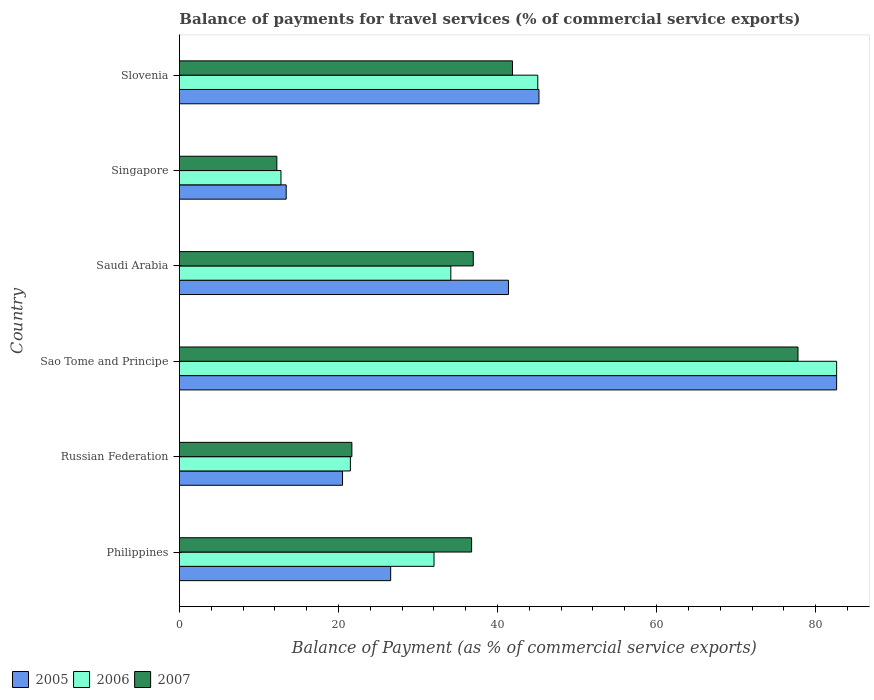How many groups of bars are there?
Make the answer very short. 6. What is the label of the 2nd group of bars from the top?
Offer a very short reply. Singapore. In how many cases, is the number of bars for a given country not equal to the number of legend labels?
Keep it short and to the point. 0. What is the balance of payments for travel services in 2007 in Singapore?
Offer a very short reply. 12.25. Across all countries, what is the maximum balance of payments for travel services in 2007?
Offer a terse response. 77.78. Across all countries, what is the minimum balance of payments for travel services in 2007?
Provide a short and direct response. 12.25. In which country was the balance of payments for travel services in 2007 maximum?
Provide a short and direct response. Sao Tome and Principe. In which country was the balance of payments for travel services in 2007 minimum?
Offer a very short reply. Singapore. What is the total balance of payments for travel services in 2005 in the graph?
Give a very brief answer. 229.74. What is the difference between the balance of payments for travel services in 2007 in Russian Federation and that in Saudi Arabia?
Provide a succinct answer. -15.27. What is the difference between the balance of payments for travel services in 2005 in Philippines and the balance of payments for travel services in 2007 in Singapore?
Provide a short and direct response. 14.31. What is the average balance of payments for travel services in 2007 per country?
Keep it short and to the point. 37.88. What is the difference between the balance of payments for travel services in 2006 and balance of payments for travel services in 2005 in Russian Federation?
Make the answer very short. 0.99. What is the ratio of the balance of payments for travel services in 2006 in Philippines to that in Russian Federation?
Your answer should be compact. 1.49. What is the difference between the highest and the second highest balance of payments for travel services in 2005?
Provide a succinct answer. 37.43. What is the difference between the highest and the lowest balance of payments for travel services in 2005?
Make the answer very short. 69.22. Is the sum of the balance of payments for travel services in 2005 in Sao Tome and Principe and Slovenia greater than the maximum balance of payments for travel services in 2006 across all countries?
Your answer should be very brief. Yes. What does the 3rd bar from the top in Philippines represents?
Provide a short and direct response. 2005. What does the 1st bar from the bottom in Saudi Arabia represents?
Ensure brevity in your answer.  2005. How many bars are there?
Keep it short and to the point. 18. How many countries are there in the graph?
Make the answer very short. 6. What is the difference between two consecutive major ticks on the X-axis?
Your response must be concise. 20. Does the graph contain grids?
Make the answer very short. No. What is the title of the graph?
Make the answer very short. Balance of payments for travel services (% of commercial service exports). Does "1999" appear as one of the legend labels in the graph?
Offer a terse response. No. What is the label or title of the X-axis?
Your answer should be compact. Balance of Payment (as % of commercial service exports). What is the Balance of Payment (as % of commercial service exports) in 2005 in Philippines?
Your response must be concise. 26.56. What is the Balance of Payment (as % of commercial service exports) in 2006 in Philippines?
Make the answer very short. 32.02. What is the Balance of Payment (as % of commercial service exports) of 2007 in Philippines?
Provide a short and direct response. 36.74. What is the Balance of Payment (as % of commercial service exports) of 2005 in Russian Federation?
Provide a short and direct response. 20.51. What is the Balance of Payment (as % of commercial service exports) of 2006 in Russian Federation?
Your response must be concise. 21.5. What is the Balance of Payment (as % of commercial service exports) of 2007 in Russian Federation?
Ensure brevity in your answer.  21.69. What is the Balance of Payment (as % of commercial service exports) of 2005 in Sao Tome and Principe?
Provide a succinct answer. 82.64. What is the Balance of Payment (as % of commercial service exports) of 2006 in Sao Tome and Principe?
Provide a succinct answer. 82.64. What is the Balance of Payment (as % of commercial service exports) in 2007 in Sao Tome and Principe?
Provide a short and direct response. 77.78. What is the Balance of Payment (as % of commercial service exports) in 2005 in Saudi Arabia?
Ensure brevity in your answer.  41.38. What is the Balance of Payment (as % of commercial service exports) in 2006 in Saudi Arabia?
Ensure brevity in your answer.  34.13. What is the Balance of Payment (as % of commercial service exports) of 2007 in Saudi Arabia?
Provide a succinct answer. 36.95. What is the Balance of Payment (as % of commercial service exports) in 2005 in Singapore?
Ensure brevity in your answer.  13.43. What is the Balance of Payment (as % of commercial service exports) of 2006 in Singapore?
Your answer should be compact. 12.77. What is the Balance of Payment (as % of commercial service exports) in 2007 in Singapore?
Make the answer very short. 12.25. What is the Balance of Payment (as % of commercial service exports) of 2005 in Slovenia?
Your answer should be very brief. 45.21. What is the Balance of Payment (as % of commercial service exports) in 2006 in Slovenia?
Your response must be concise. 45.06. What is the Balance of Payment (as % of commercial service exports) of 2007 in Slovenia?
Provide a succinct answer. 41.88. Across all countries, what is the maximum Balance of Payment (as % of commercial service exports) in 2005?
Offer a very short reply. 82.64. Across all countries, what is the maximum Balance of Payment (as % of commercial service exports) in 2006?
Give a very brief answer. 82.64. Across all countries, what is the maximum Balance of Payment (as % of commercial service exports) in 2007?
Your answer should be very brief. 77.78. Across all countries, what is the minimum Balance of Payment (as % of commercial service exports) in 2005?
Provide a succinct answer. 13.43. Across all countries, what is the minimum Balance of Payment (as % of commercial service exports) of 2006?
Your answer should be compact. 12.77. Across all countries, what is the minimum Balance of Payment (as % of commercial service exports) in 2007?
Provide a succinct answer. 12.25. What is the total Balance of Payment (as % of commercial service exports) of 2005 in the graph?
Ensure brevity in your answer.  229.74. What is the total Balance of Payment (as % of commercial service exports) of 2006 in the graph?
Ensure brevity in your answer.  228.12. What is the total Balance of Payment (as % of commercial service exports) of 2007 in the graph?
Ensure brevity in your answer.  227.3. What is the difference between the Balance of Payment (as % of commercial service exports) in 2005 in Philippines and that in Russian Federation?
Keep it short and to the point. 6.05. What is the difference between the Balance of Payment (as % of commercial service exports) in 2006 in Philippines and that in Russian Federation?
Your response must be concise. 10.52. What is the difference between the Balance of Payment (as % of commercial service exports) in 2007 in Philippines and that in Russian Federation?
Offer a terse response. 15.06. What is the difference between the Balance of Payment (as % of commercial service exports) in 2005 in Philippines and that in Sao Tome and Principe?
Give a very brief answer. -56.08. What is the difference between the Balance of Payment (as % of commercial service exports) of 2006 in Philippines and that in Sao Tome and Principe?
Your answer should be very brief. -50.63. What is the difference between the Balance of Payment (as % of commercial service exports) in 2007 in Philippines and that in Sao Tome and Principe?
Provide a short and direct response. -41.04. What is the difference between the Balance of Payment (as % of commercial service exports) of 2005 in Philippines and that in Saudi Arabia?
Your response must be concise. -14.81. What is the difference between the Balance of Payment (as % of commercial service exports) in 2006 in Philippines and that in Saudi Arabia?
Your answer should be compact. -2.11. What is the difference between the Balance of Payment (as % of commercial service exports) of 2007 in Philippines and that in Saudi Arabia?
Your response must be concise. -0.21. What is the difference between the Balance of Payment (as % of commercial service exports) of 2005 in Philippines and that in Singapore?
Provide a short and direct response. 13.14. What is the difference between the Balance of Payment (as % of commercial service exports) in 2006 in Philippines and that in Singapore?
Provide a succinct answer. 19.25. What is the difference between the Balance of Payment (as % of commercial service exports) in 2007 in Philippines and that in Singapore?
Offer a very short reply. 24.49. What is the difference between the Balance of Payment (as % of commercial service exports) of 2005 in Philippines and that in Slovenia?
Offer a terse response. -18.65. What is the difference between the Balance of Payment (as % of commercial service exports) of 2006 in Philippines and that in Slovenia?
Provide a succinct answer. -13.05. What is the difference between the Balance of Payment (as % of commercial service exports) of 2007 in Philippines and that in Slovenia?
Give a very brief answer. -5.14. What is the difference between the Balance of Payment (as % of commercial service exports) in 2005 in Russian Federation and that in Sao Tome and Principe?
Provide a short and direct response. -62.13. What is the difference between the Balance of Payment (as % of commercial service exports) in 2006 in Russian Federation and that in Sao Tome and Principe?
Your answer should be compact. -61.15. What is the difference between the Balance of Payment (as % of commercial service exports) of 2007 in Russian Federation and that in Sao Tome and Principe?
Make the answer very short. -56.1. What is the difference between the Balance of Payment (as % of commercial service exports) in 2005 in Russian Federation and that in Saudi Arabia?
Provide a succinct answer. -20.87. What is the difference between the Balance of Payment (as % of commercial service exports) of 2006 in Russian Federation and that in Saudi Arabia?
Keep it short and to the point. -12.63. What is the difference between the Balance of Payment (as % of commercial service exports) of 2007 in Russian Federation and that in Saudi Arabia?
Give a very brief answer. -15.27. What is the difference between the Balance of Payment (as % of commercial service exports) in 2005 in Russian Federation and that in Singapore?
Your answer should be very brief. 7.08. What is the difference between the Balance of Payment (as % of commercial service exports) of 2006 in Russian Federation and that in Singapore?
Keep it short and to the point. 8.73. What is the difference between the Balance of Payment (as % of commercial service exports) in 2007 in Russian Federation and that in Singapore?
Your answer should be very brief. 9.43. What is the difference between the Balance of Payment (as % of commercial service exports) in 2005 in Russian Federation and that in Slovenia?
Give a very brief answer. -24.7. What is the difference between the Balance of Payment (as % of commercial service exports) of 2006 in Russian Federation and that in Slovenia?
Your answer should be very brief. -23.57. What is the difference between the Balance of Payment (as % of commercial service exports) of 2007 in Russian Federation and that in Slovenia?
Make the answer very short. -20.2. What is the difference between the Balance of Payment (as % of commercial service exports) in 2005 in Sao Tome and Principe and that in Saudi Arabia?
Ensure brevity in your answer.  41.26. What is the difference between the Balance of Payment (as % of commercial service exports) of 2006 in Sao Tome and Principe and that in Saudi Arabia?
Give a very brief answer. 48.52. What is the difference between the Balance of Payment (as % of commercial service exports) in 2007 in Sao Tome and Principe and that in Saudi Arabia?
Your response must be concise. 40.83. What is the difference between the Balance of Payment (as % of commercial service exports) in 2005 in Sao Tome and Principe and that in Singapore?
Give a very brief answer. 69.22. What is the difference between the Balance of Payment (as % of commercial service exports) in 2006 in Sao Tome and Principe and that in Singapore?
Your response must be concise. 69.87. What is the difference between the Balance of Payment (as % of commercial service exports) in 2007 in Sao Tome and Principe and that in Singapore?
Your response must be concise. 65.53. What is the difference between the Balance of Payment (as % of commercial service exports) in 2005 in Sao Tome and Principe and that in Slovenia?
Your answer should be very brief. 37.43. What is the difference between the Balance of Payment (as % of commercial service exports) in 2006 in Sao Tome and Principe and that in Slovenia?
Provide a succinct answer. 37.58. What is the difference between the Balance of Payment (as % of commercial service exports) of 2007 in Sao Tome and Principe and that in Slovenia?
Make the answer very short. 35.9. What is the difference between the Balance of Payment (as % of commercial service exports) in 2005 in Saudi Arabia and that in Singapore?
Make the answer very short. 27.95. What is the difference between the Balance of Payment (as % of commercial service exports) in 2006 in Saudi Arabia and that in Singapore?
Offer a terse response. 21.36. What is the difference between the Balance of Payment (as % of commercial service exports) of 2007 in Saudi Arabia and that in Singapore?
Your answer should be very brief. 24.7. What is the difference between the Balance of Payment (as % of commercial service exports) of 2005 in Saudi Arabia and that in Slovenia?
Offer a terse response. -3.83. What is the difference between the Balance of Payment (as % of commercial service exports) in 2006 in Saudi Arabia and that in Slovenia?
Your answer should be very brief. -10.94. What is the difference between the Balance of Payment (as % of commercial service exports) in 2007 in Saudi Arabia and that in Slovenia?
Ensure brevity in your answer.  -4.93. What is the difference between the Balance of Payment (as % of commercial service exports) of 2005 in Singapore and that in Slovenia?
Make the answer very short. -31.79. What is the difference between the Balance of Payment (as % of commercial service exports) in 2006 in Singapore and that in Slovenia?
Offer a very short reply. -32.29. What is the difference between the Balance of Payment (as % of commercial service exports) in 2007 in Singapore and that in Slovenia?
Provide a short and direct response. -29.63. What is the difference between the Balance of Payment (as % of commercial service exports) of 2005 in Philippines and the Balance of Payment (as % of commercial service exports) of 2006 in Russian Federation?
Keep it short and to the point. 5.07. What is the difference between the Balance of Payment (as % of commercial service exports) of 2005 in Philippines and the Balance of Payment (as % of commercial service exports) of 2007 in Russian Federation?
Offer a terse response. 4.88. What is the difference between the Balance of Payment (as % of commercial service exports) in 2006 in Philippines and the Balance of Payment (as % of commercial service exports) in 2007 in Russian Federation?
Your response must be concise. 10.33. What is the difference between the Balance of Payment (as % of commercial service exports) of 2005 in Philippines and the Balance of Payment (as % of commercial service exports) of 2006 in Sao Tome and Principe?
Make the answer very short. -56.08. What is the difference between the Balance of Payment (as % of commercial service exports) in 2005 in Philippines and the Balance of Payment (as % of commercial service exports) in 2007 in Sao Tome and Principe?
Offer a terse response. -51.22. What is the difference between the Balance of Payment (as % of commercial service exports) of 2006 in Philippines and the Balance of Payment (as % of commercial service exports) of 2007 in Sao Tome and Principe?
Provide a succinct answer. -45.77. What is the difference between the Balance of Payment (as % of commercial service exports) in 2005 in Philippines and the Balance of Payment (as % of commercial service exports) in 2006 in Saudi Arabia?
Offer a very short reply. -7.56. What is the difference between the Balance of Payment (as % of commercial service exports) in 2005 in Philippines and the Balance of Payment (as % of commercial service exports) in 2007 in Saudi Arabia?
Your answer should be very brief. -10.39. What is the difference between the Balance of Payment (as % of commercial service exports) of 2006 in Philippines and the Balance of Payment (as % of commercial service exports) of 2007 in Saudi Arabia?
Provide a succinct answer. -4.94. What is the difference between the Balance of Payment (as % of commercial service exports) of 2005 in Philippines and the Balance of Payment (as % of commercial service exports) of 2006 in Singapore?
Provide a short and direct response. 13.79. What is the difference between the Balance of Payment (as % of commercial service exports) of 2005 in Philippines and the Balance of Payment (as % of commercial service exports) of 2007 in Singapore?
Provide a succinct answer. 14.31. What is the difference between the Balance of Payment (as % of commercial service exports) of 2006 in Philippines and the Balance of Payment (as % of commercial service exports) of 2007 in Singapore?
Your answer should be compact. 19.76. What is the difference between the Balance of Payment (as % of commercial service exports) in 2005 in Philippines and the Balance of Payment (as % of commercial service exports) in 2006 in Slovenia?
Give a very brief answer. -18.5. What is the difference between the Balance of Payment (as % of commercial service exports) of 2005 in Philippines and the Balance of Payment (as % of commercial service exports) of 2007 in Slovenia?
Your answer should be very brief. -15.32. What is the difference between the Balance of Payment (as % of commercial service exports) in 2006 in Philippines and the Balance of Payment (as % of commercial service exports) in 2007 in Slovenia?
Offer a terse response. -9.87. What is the difference between the Balance of Payment (as % of commercial service exports) of 2005 in Russian Federation and the Balance of Payment (as % of commercial service exports) of 2006 in Sao Tome and Principe?
Make the answer very short. -62.13. What is the difference between the Balance of Payment (as % of commercial service exports) of 2005 in Russian Federation and the Balance of Payment (as % of commercial service exports) of 2007 in Sao Tome and Principe?
Offer a terse response. -57.27. What is the difference between the Balance of Payment (as % of commercial service exports) of 2006 in Russian Federation and the Balance of Payment (as % of commercial service exports) of 2007 in Sao Tome and Principe?
Your answer should be compact. -56.29. What is the difference between the Balance of Payment (as % of commercial service exports) in 2005 in Russian Federation and the Balance of Payment (as % of commercial service exports) in 2006 in Saudi Arabia?
Keep it short and to the point. -13.61. What is the difference between the Balance of Payment (as % of commercial service exports) of 2005 in Russian Federation and the Balance of Payment (as % of commercial service exports) of 2007 in Saudi Arabia?
Give a very brief answer. -16.44. What is the difference between the Balance of Payment (as % of commercial service exports) in 2006 in Russian Federation and the Balance of Payment (as % of commercial service exports) in 2007 in Saudi Arabia?
Your answer should be compact. -15.45. What is the difference between the Balance of Payment (as % of commercial service exports) of 2005 in Russian Federation and the Balance of Payment (as % of commercial service exports) of 2006 in Singapore?
Keep it short and to the point. 7.74. What is the difference between the Balance of Payment (as % of commercial service exports) in 2005 in Russian Federation and the Balance of Payment (as % of commercial service exports) in 2007 in Singapore?
Make the answer very short. 8.26. What is the difference between the Balance of Payment (as % of commercial service exports) of 2006 in Russian Federation and the Balance of Payment (as % of commercial service exports) of 2007 in Singapore?
Your answer should be very brief. 9.25. What is the difference between the Balance of Payment (as % of commercial service exports) in 2005 in Russian Federation and the Balance of Payment (as % of commercial service exports) in 2006 in Slovenia?
Give a very brief answer. -24.55. What is the difference between the Balance of Payment (as % of commercial service exports) of 2005 in Russian Federation and the Balance of Payment (as % of commercial service exports) of 2007 in Slovenia?
Your answer should be compact. -21.37. What is the difference between the Balance of Payment (as % of commercial service exports) of 2006 in Russian Federation and the Balance of Payment (as % of commercial service exports) of 2007 in Slovenia?
Your answer should be very brief. -20.38. What is the difference between the Balance of Payment (as % of commercial service exports) of 2005 in Sao Tome and Principe and the Balance of Payment (as % of commercial service exports) of 2006 in Saudi Arabia?
Make the answer very short. 48.52. What is the difference between the Balance of Payment (as % of commercial service exports) in 2005 in Sao Tome and Principe and the Balance of Payment (as % of commercial service exports) in 2007 in Saudi Arabia?
Your answer should be compact. 45.69. What is the difference between the Balance of Payment (as % of commercial service exports) of 2006 in Sao Tome and Principe and the Balance of Payment (as % of commercial service exports) of 2007 in Saudi Arabia?
Provide a succinct answer. 45.69. What is the difference between the Balance of Payment (as % of commercial service exports) of 2005 in Sao Tome and Principe and the Balance of Payment (as % of commercial service exports) of 2006 in Singapore?
Give a very brief answer. 69.87. What is the difference between the Balance of Payment (as % of commercial service exports) of 2005 in Sao Tome and Principe and the Balance of Payment (as % of commercial service exports) of 2007 in Singapore?
Give a very brief answer. 70.39. What is the difference between the Balance of Payment (as % of commercial service exports) in 2006 in Sao Tome and Principe and the Balance of Payment (as % of commercial service exports) in 2007 in Singapore?
Ensure brevity in your answer.  70.39. What is the difference between the Balance of Payment (as % of commercial service exports) in 2005 in Sao Tome and Principe and the Balance of Payment (as % of commercial service exports) in 2006 in Slovenia?
Offer a terse response. 37.58. What is the difference between the Balance of Payment (as % of commercial service exports) of 2005 in Sao Tome and Principe and the Balance of Payment (as % of commercial service exports) of 2007 in Slovenia?
Offer a very short reply. 40.76. What is the difference between the Balance of Payment (as % of commercial service exports) in 2006 in Sao Tome and Principe and the Balance of Payment (as % of commercial service exports) in 2007 in Slovenia?
Offer a terse response. 40.76. What is the difference between the Balance of Payment (as % of commercial service exports) of 2005 in Saudi Arabia and the Balance of Payment (as % of commercial service exports) of 2006 in Singapore?
Your answer should be compact. 28.61. What is the difference between the Balance of Payment (as % of commercial service exports) of 2005 in Saudi Arabia and the Balance of Payment (as % of commercial service exports) of 2007 in Singapore?
Offer a terse response. 29.13. What is the difference between the Balance of Payment (as % of commercial service exports) in 2006 in Saudi Arabia and the Balance of Payment (as % of commercial service exports) in 2007 in Singapore?
Ensure brevity in your answer.  21.87. What is the difference between the Balance of Payment (as % of commercial service exports) in 2005 in Saudi Arabia and the Balance of Payment (as % of commercial service exports) in 2006 in Slovenia?
Offer a terse response. -3.69. What is the difference between the Balance of Payment (as % of commercial service exports) of 2005 in Saudi Arabia and the Balance of Payment (as % of commercial service exports) of 2007 in Slovenia?
Your answer should be very brief. -0.5. What is the difference between the Balance of Payment (as % of commercial service exports) in 2006 in Saudi Arabia and the Balance of Payment (as % of commercial service exports) in 2007 in Slovenia?
Your response must be concise. -7.75. What is the difference between the Balance of Payment (as % of commercial service exports) in 2005 in Singapore and the Balance of Payment (as % of commercial service exports) in 2006 in Slovenia?
Offer a terse response. -31.64. What is the difference between the Balance of Payment (as % of commercial service exports) of 2005 in Singapore and the Balance of Payment (as % of commercial service exports) of 2007 in Slovenia?
Provide a succinct answer. -28.45. What is the difference between the Balance of Payment (as % of commercial service exports) in 2006 in Singapore and the Balance of Payment (as % of commercial service exports) in 2007 in Slovenia?
Offer a terse response. -29.11. What is the average Balance of Payment (as % of commercial service exports) in 2005 per country?
Provide a succinct answer. 38.29. What is the average Balance of Payment (as % of commercial service exports) in 2006 per country?
Provide a short and direct response. 38.02. What is the average Balance of Payment (as % of commercial service exports) of 2007 per country?
Your answer should be compact. 37.88. What is the difference between the Balance of Payment (as % of commercial service exports) of 2005 and Balance of Payment (as % of commercial service exports) of 2006 in Philippines?
Your answer should be very brief. -5.45. What is the difference between the Balance of Payment (as % of commercial service exports) in 2005 and Balance of Payment (as % of commercial service exports) in 2007 in Philippines?
Make the answer very short. -10.18. What is the difference between the Balance of Payment (as % of commercial service exports) of 2006 and Balance of Payment (as % of commercial service exports) of 2007 in Philippines?
Ensure brevity in your answer.  -4.73. What is the difference between the Balance of Payment (as % of commercial service exports) of 2005 and Balance of Payment (as % of commercial service exports) of 2006 in Russian Federation?
Offer a very short reply. -0.99. What is the difference between the Balance of Payment (as % of commercial service exports) of 2005 and Balance of Payment (as % of commercial service exports) of 2007 in Russian Federation?
Your answer should be very brief. -1.17. What is the difference between the Balance of Payment (as % of commercial service exports) of 2006 and Balance of Payment (as % of commercial service exports) of 2007 in Russian Federation?
Provide a succinct answer. -0.19. What is the difference between the Balance of Payment (as % of commercial service exports) in 2005 and Balance of Payment (as % of commercial service exports) in 2007 in Sao Tome and Principe?
Offer a very short reply. 4.86. What is the difference between the Balance of Payment (as % of commercial service exports) of 2006 and Balance of Payment (as % of commercial service exports) of 2007 in Sao Tome and Principe?
Your response must be concise. 4.86. What is the difference between the Balance of Payment (as % of commercial service exports) of 2005 and Balance of Payment (as % of commercial service exports) of 2006 in Saudi Arabia?
Give a very brief answer. 7.25. What is the difference between the Balance of Payment (as % of commercial service exports) of 2005 and Balance of Payment (as % of commercial service exports) of 2007 in Saudi Arabia?
Provide a succinct answer. 4.43. What is the difference between the Balance of Payment (as % of commercial service exports) of 2006 and Balance of Payment (as % of commercial service exports) of 2007 in Saudi Arabia?
Offer a terse response. -2.82. What is the difference between the Balance of Payment (as % of commercial service exports) of 2005 and Balance of Payment (as % of commercial service exports) of 2006 in Singapore?
Your answer should be compact. 0.66. What is the difference between the Balance of Payment (as % of commercial service exports) of 2005 and Balance of Payment (as % of commercial service exports) of 2007 in Singapore?
Provide a succinct answer. 1.17. What is the difference between the Balance of Payment (as % of commercial service exports) of 2006 and Balance of Payment (as % of commercial service exports) of 2007 in Singapore?
Your answer should be very brief. 0.52. What is the difference between the Balance of Payment (as % of commercial service exports) in 2005 and Balance of Payment (as % of commercial service exports) in 2006 in Slovenia?
Offer a very short reply. 0.15. What is the difference between the Balance of Payment (as % of commercial service exports) of 2005 and Balance of Payment (as % of commercial service exports) of 2007 in Slovenia?
Your answer should be compact. 3.33. What is the difference between the Balance of Payment (as % of commercial service exports) in 2006 and Balance of Payment (as % of commercial service exports) in 2007 in Slovenia?
Your response must be concise. 3.18. What is the ratio of the Balance of Payment (as % of commercial service exports) in 2005 in Philippines to that in Russian Federation?
Give a very brief answer. 1.3. What is the ratio of the Balance of Payment (as % of commercial service exports) of 2006 in Philippines to that in Russian Federation?
Make the answer very short. 1.49. What is the ratio of the Balance of Payment (as % of commercial service exports) of 2007 in Philippines to that in Russian Federation?
Offer a terse response. 1.69. What is the ratio of the Balance of Payment (as % of commercial service exports) of 2005 in Philippines to that in Sao Tome and Principe?
Give a very brief answer. 0.32. What is the ratio of the Balance of Payment (as % of commercial service exports) of 2006 in Philippines to that in Sao Tome and Principe?
Offer a terse response. 0.39. What is the ratio of the Balance of Payment (as % of commercial service exports) in 2007 in Philippines to that in Sao Tome and Principe?
Provide a succinct answer. 0.47. What is the ratio of the Balance of Payment (as % of commercial service exports) in 2005 in Philippines to that in Saudi Arabia?
Your answer should be compact. 0.64. What is the ratio of the Balance of Payment (as % of commercial service exports) in 2006 in Philippines to that in Saudi Arabia?
Make the answer very short. 0.94. What is the ratio of the Balance of Payment (as % of commercial service exports) of 2005 in Philippines to that in Singapore?
Offer a very short reply. 1.98. What is the ratio of the Balance of Payment (as % of commercial service exports) of 2006 in Philippines to that in Singapore?
Give a very brief answer. 2.51. What is the ratio of the Balance of Payment (as % of commercial service exports) of 2007 in Philippines to that in Singapore?
Offer a very short reply. 3. What is the ratio of the Balance of Payment (as % of commercial service exports) in 2005 in Philippines to that in Slovenia?
Give a very brief answer. 0.59. What is the ratio of the Balance of Payment (as % of commercial service exports) in 2006 in Philippines to that in Slovenia?
Provide a succinct answer. 0.71. What is the ratio of the Balance of Payment (as % of commercial service exports) in 2007 in Philippines to that in Slovenia?
Give a very brief answer. 0.88. What is the ratio of the Balance of Payment (as % of commercial service exports) in 2005 in Russian Federation to that in Sao Tome and Principe?
Provide a succinct answer. 0.25. What is the ratio of the Balance of Payment (as % of commercial service exports) in 2006 in Russian Federation to that in Sao Tome and Principe?
Offer a very short reply. 0.26. What is the ratio of the Balance of Payment (as % of commercial service exports) in 2007 in Russian Federation to that in Sao Tome and Principe?
Make the answer very short. 0.28. What is the ratio of the Balance of Payment (as % of commercial service exports) in 2005 in Russian Federation to that in Saudi Arabia?
Offer a terse response. 0.5. What is the ratio of the Balance of Payment (as % of commercial service exports) in 2006 in Russian Federation to that in Saudi Arabia?
Provide a short and direct response. 0.63. What is the ratio of the Balance of Payment (as % of commercial service exports) of 2007 in Russian Federation to that in Saudi Arabia?
Keep it short and to the point. 0.59. What is the ratio of the Balance of Payment (as % of commercial service exports) of 2005 in Russian Federation to that in Singapore?
Provide a short and direct response. 1.53. What is the ratio of the Balance of Payment (as % of commercial service exports) in 2006 in Russian Federation to that in Singapore?
Ensure brevity in your answer.  1.68. What is the ratio of the Balance of Payment (as % of commercial service exports) in 2007 in Russian Federation to that in Singapore?
Offer a very short reply. 1.77. What is the ratio of the Balance of Payment (as % of commercial service exports) in 2005 in Russian Federation to that in Slovenia?
Provide a short and direct response. 0.45. What is the ratio of the Balance of Payment (as % of commercial service exports) in 2006 in Russian Federation to that in Slovenia?
Offer a very short reply. 0.48. What is the ratio of the Balance of Payment (as % of commercial service exports) of 2007 in Russian Federation to that in Slovenia?
Provide a short and direct response. 0.52. What is the ratio of the Balance of Payment (as % of commercial service exports) of 2005 in Sao Tome and Principe to that in Saudi Arabia?
Provide a short and direct response. 2. What is the ratio of the Balance of Payment (as % of commercial service exports) in 2006 in Sao Tome and Principe to that in Saudi Arabia?
Provide a short and direct response. 2.42. What is the ratio of the Balance of Payment (as % of commercial service exports) in 2007 in Sao Tome and Principe to that in Saudi Arabia?
Provide a succinct answer. 2.1. What is the ratio of the Balance of Payment (as % of commercial service exports) in 2005 in Sao Tome and Principe to that in Singapore?
Provide a short and direct response. 6.15. What is the ratio of the Balance of Payment (as % of commercial service exports) in 2006 in Sao Tome and Principe to that in Singapore?
Ensure brevity in your answer.  6.47. What is the ratio of the Balance of Payment (as % of commercial service exports) in 2007 in Sao Tome and Principe to that in Singapore?
Your answer should be compact. 6.35. What is the ratio of the Balance of Payment (as % of commercial service exports) of 2005 in Sao Tome and Principe to that in Slovenia?
Offer a very short reply. 1.83. What is the ratio of the Balance of Payment (as % of commercial service exports) in 2006 in Sao Tome and Principe to that in Slovenia?
Your answer should be compact. 1.83. What is the ratio of the Balance of Payment (as % of commercial service exports) in 2007 in Sao Tome and Principe to that in Slovenia?
Give a very brief answer. 1.86. What is the ratio of the Balance of Payment (as % of commercial service exports) of 2005 in Saudi Arabia to that in Singapore?
Your response must be concise. 3.08. What is the ratio of the Balance of Payment (as % of commercial service exports) in 2006 in Saudi Arabia to that in Singapore?
Give a very brief answer. 2.67. What is the ratio of the Balance of Payment (as % of commercial service exports) in 2007 in Saudi Arabia to that in Singapore?
Provide a succinct answer. 3.02. What is the ratio of the Balance of Payment (as % of commercial service exports) in 2005 in Saudi Arabia to that in Slovenia?
Provide a succinct answer. 0.92. What is the ratio of the Balance of Payment (as % of commercial service exports) of 2006 in Saudi Arabia to that in Slovenia?
Your answer should be very brief. 0.76. What is the ratio of the Balance of Payment (as % of commercial service exports) in 2007 in Saudi Arabia to that in Slovenia?
Offer a terse response. 0.88. What is the ratio of the Balance of Payment (as % of commercial service exports) in 2005 in Singapore to that in Slovenia?
Provide a short and direct response. 0.3. What is the ratio of the Balance of Payment (as % of commercial service exports) in 2006 in Singapore to that in Slovenia?
Provide a short and direct response. 0.28. What is the ratio of the Balance of Payment (as % of commercial service exports) in 2007 in Singapore to that in Slovenia?
Your answer should be very brief. 0.29. What is the difference between the highest and the second highest Balance of Payment (as % of commercial service exports) in 2005?
Ensure brevity in your answer.  37.43. What is the difference between the highest and the second highest Balance of Payment (as % of commercial service exports) of 2006?
Offer a very short reply. 37.58. What is the difference between the highest and the second highest Balance of Payment (as % of commercial service exports) of 2007?
Your answer should be compact. 35.9. What is the difference between the highest and the lowest Balance of Payment (as % of commercial service exports) of 2005?
Provide a succinct answer. 69.22. What is the difference between the highest and the lowest Balance of Payment (as % of commercial service exports) in 2006?
Keep it short and to the point. 69.87. What is the difference between the highest and the lowest Balance of Payment (as % of commercial service exports) in 2007?
Ensure brevity in your answer.  65.53. 